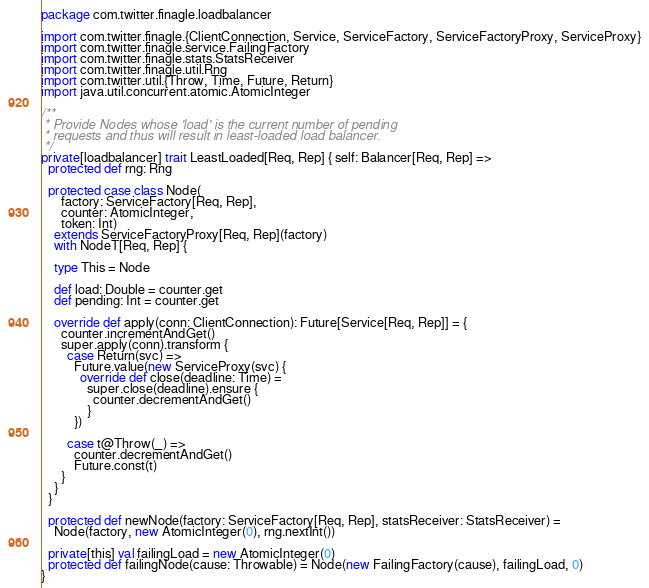<code> <loc_0><loc_0><loc_500><loc_500><_Scala_>package com.twitter.finagle.loadbalancer

import com.twitter.finagle.{ClientConnection, Service, ServiceFactory, ServiceFactoryProxy, ServiceProxy}
import com.twitter.finagle.service.FailingFactory
import com.twitter.finagle.stats.StatsReceiver
import com.twitter.finagle.util.Rng
import com.twitter.util.{Throw, Time, Future, Return}
import java.util.concurrent.atomic.AtomicInteger

/**
 * Provide Nodes whose 'load' is the current number of pending
 * requests and thus will result in least-loaded load balancer.
 */
private[loadbalancer] trait LeastLoaded[Req, Rep] { self: Balancer[Req, Rep] =>
  protected def rng: Rng

  protected case class Node(
      factory: ServiceFactory[Req, Rep],
      counter: AtomicInteger,
      token: Int)
    extends ServiceFactoryProxy[Req, Rep](factory)
    with NodeT[Req, Rep] {

    type This = Node

    def load: Double = counter.get
    def pending: Int = counter.get

    override def apply(conn: ClientConnection): Future[Service[Req, Rep]] = {
      counter.incrementAndGet()
      super.apply(conn).transform {
        case Return(svc) =>
          Future.value(new ServiceProxy(svc) {
            override def close(deadline: Time) =
              super.close(deadline).ensure {
                counter.decrementAndGet()
              }
          })

        case t@Throw(_) =>
          counter.decrementAndGet()
          Future.const(t)
      }
    }
  }

  protected def newNode(factory: ServiceFactory[Req, Rep], statsReceiver: StatsReceiver) =
    Node(factory, new AtomicInteger(0), rng.nextInt())

  private[this] val failingLoad = new AtomicInteger(0)
  protected def failingNode(cause: Throwable) = Node(new FailingFactory(cause), failingLoad, 0)
}
</code> 